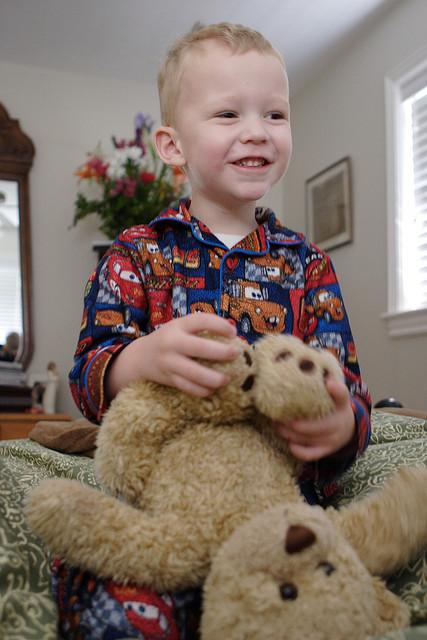What Disney movie is the theme of the boy's pj's?
Short answer required. Cars. What  color are the child's eyes?
Write a very short answer. Brown. What is he holding in his hand?
Answer briefly. Teddy bear. What is the boy playing with?
Short answer required. Teddy bear. What activity are the bears partaking in?
Short answer required. Playing. Is this a man or a woman's hand?
Give a very brief answer. Man. What color is the nose on the teddy bear to the right?
Short answer required. Brown. 